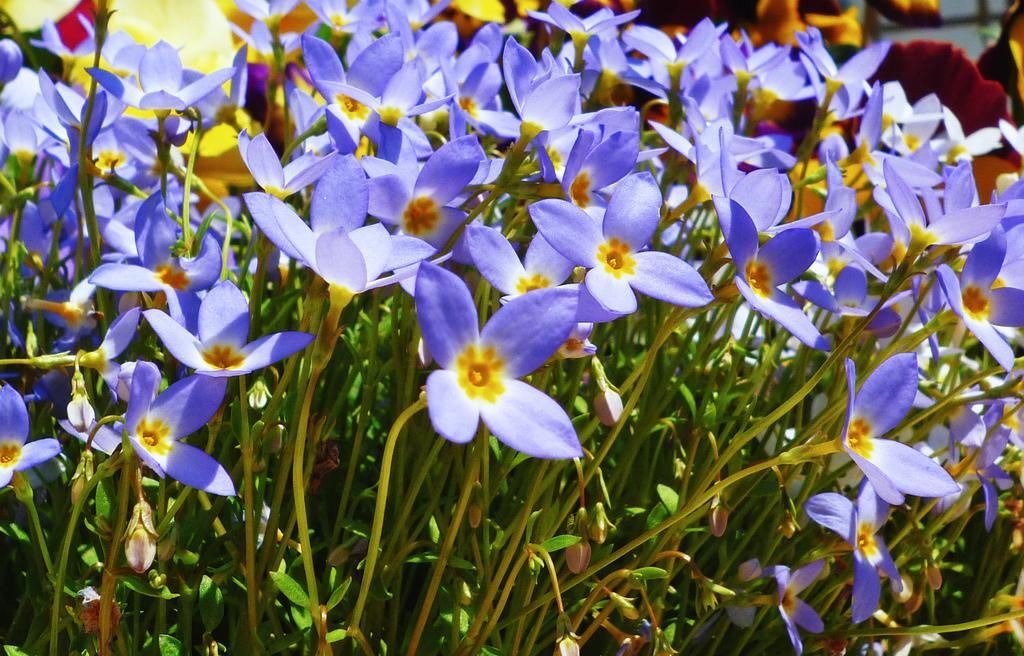What type of living organisms can be seen in the image? There are flowers and plants in the image. Can you describe the plants in the image? The plants in the image are not specified, but they are present alongside the flowers. What finger is used to water the plants in the image? There is no person or finger visible in the image, so it is not possible to determine which finger might be used to water the plants. 